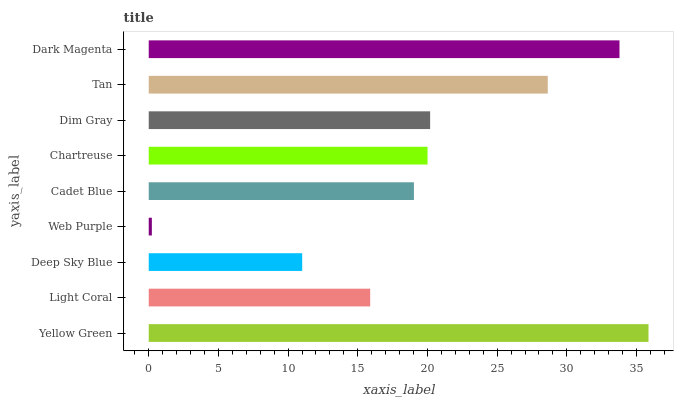Is Web Purple the minimum?
Answer yes or no. Yes. Is Yellow Green the maximum?
Answer yes or no. Yes. Is Light Coral the minimum?
Answer yes or no. No. Is Light Coral the maximum?
Answer yes or no. No. Is Yellow Green greater than Light Coral?
Answer yes or no. Yes. Is Light Coral less than Yellow Green?
Answer yes or no. Yes. Is Light Coral greater than Yellow Green?
Answer yes or no. No. Is Yellow Green less than Light Coral?
Answer yes or no. No. Is Chartreuse the high median?
Answer yes or no. Yes. Is Chartreuse the low median?
Answer yes or no. Yes. Is Dark Magenta the high median?
Answer yes or no. No. Is Yellow Green the low median?
Answer yes or no. No. 